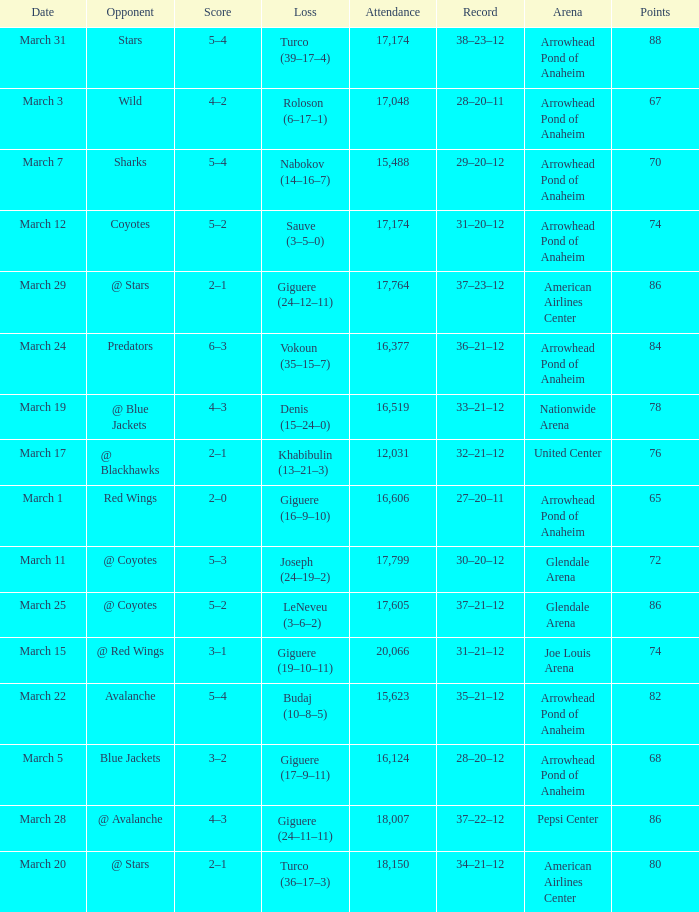What is the Score of the game on March 19? 4–3. 